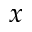Convert formula to latex. <formula><loc_0><loc_0><loc_500><loc_500>x</formula> 